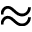<formula> <loc_0><loc_0><loc_500><loc_500>\approx</formula> 